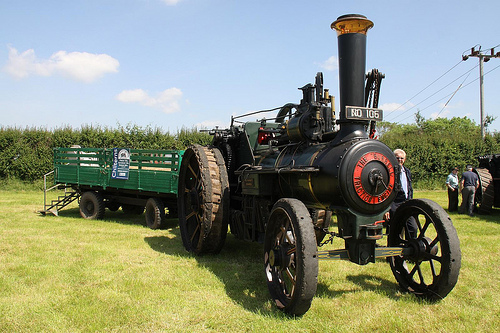<image>
Is the man in front of the vehicle? No. The man is not in front of the vehicle. The spatial positioning shows a different relationship between these objects. 